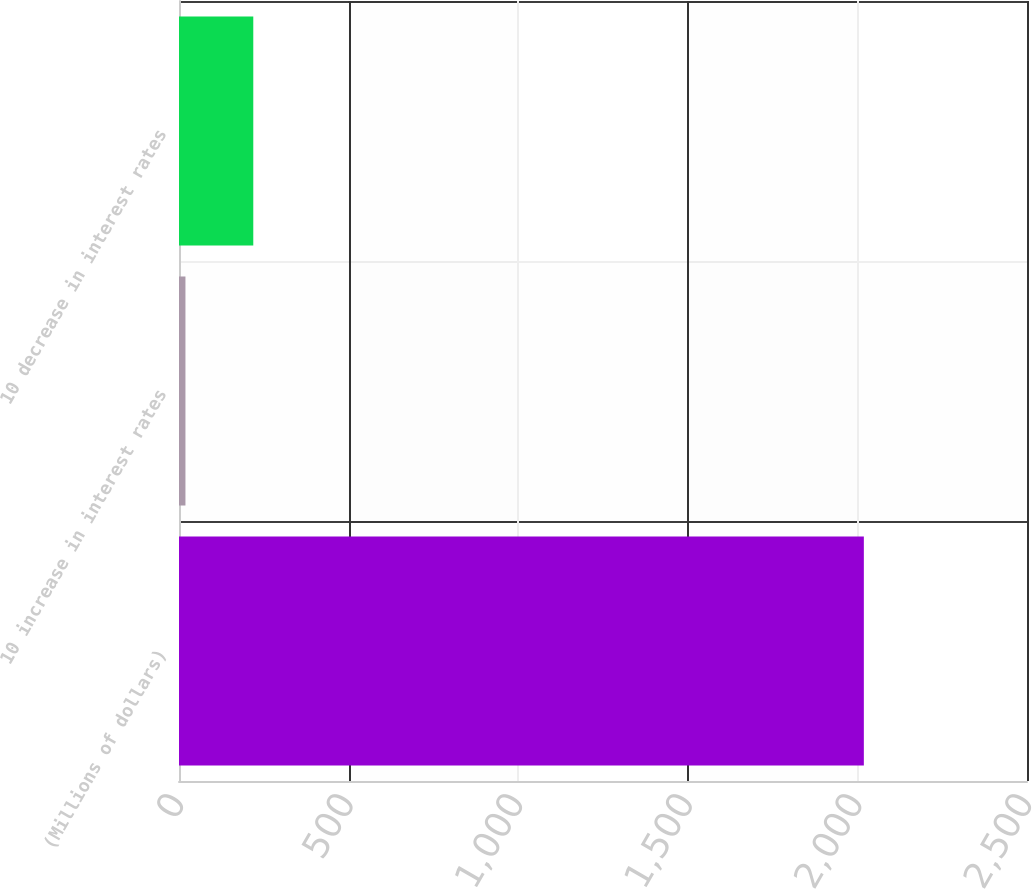Convert chart. <chart><loc_0><loc_0><loc_500><loc_500><bar_chart><fcel>(Millions of dollars)<fcel>10 increase in interest rates<fcel>10 decrease in interest rates<nl><fcel>2019<fcel>19<fcel>219<nl></chart> 